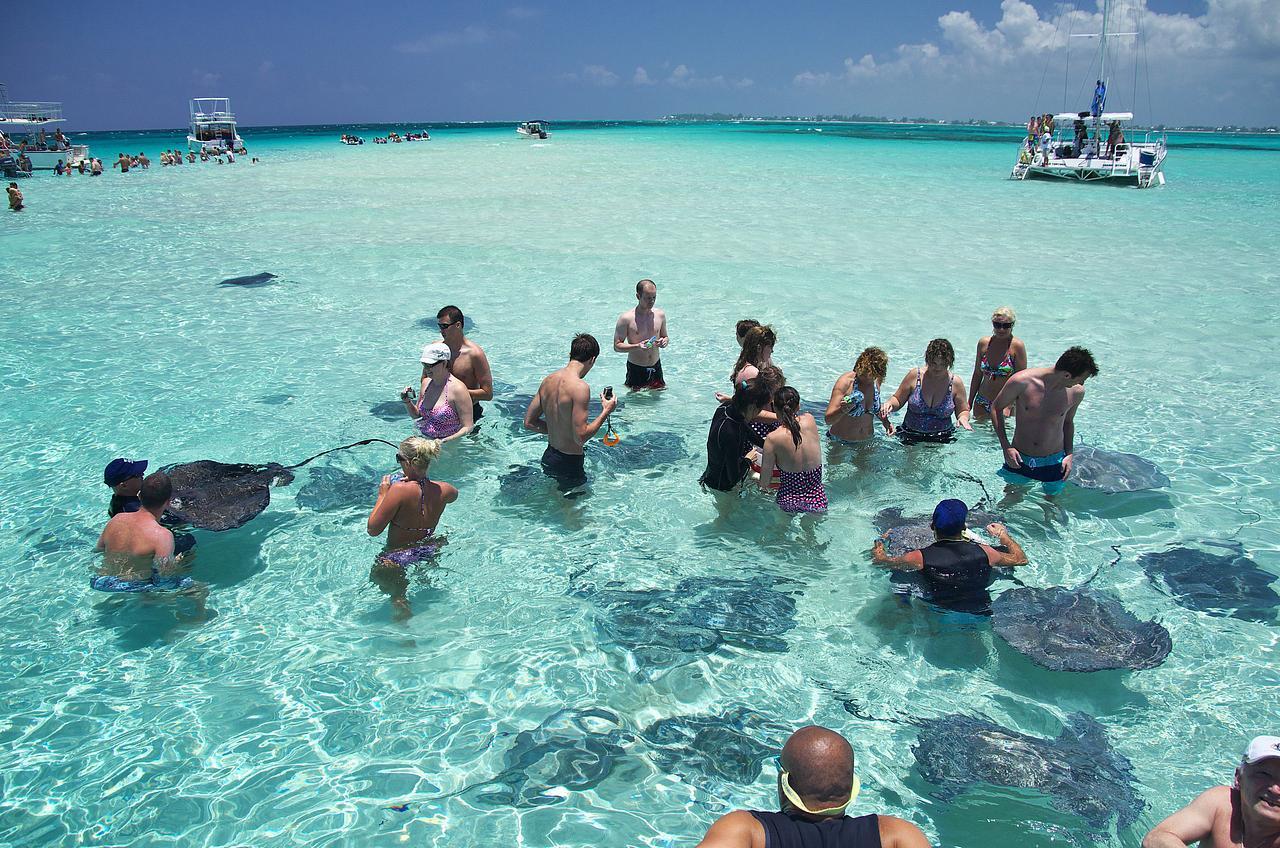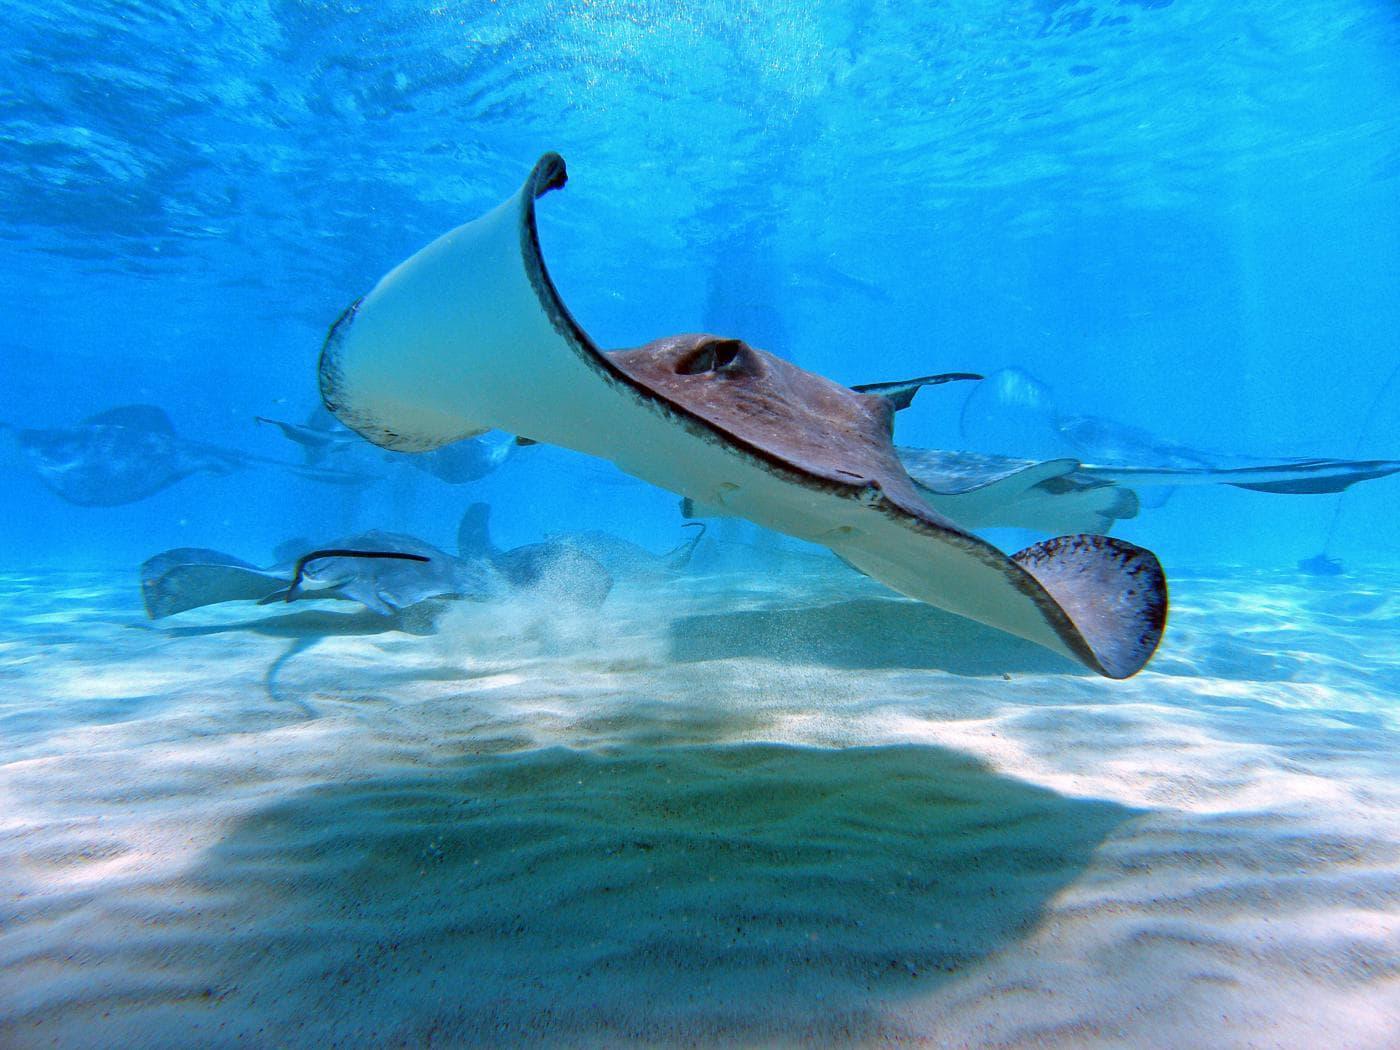The first image is the image on the left, the second image is the image on the right. Assess this claim about the two images: "One image shows one person with goggles completely underwater near stingrays.". Correct or not? Answer yes or no. No. 